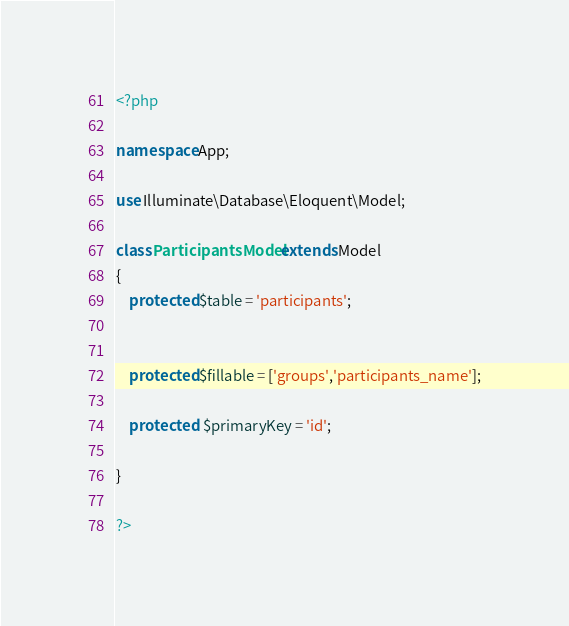<code> <loc_0><loc_0><loc_500><loc_500><_PHP_><?php

namespace App;

use Illuminate\Database\Eloquent\Model;

class ParticipantsModel extends Model
{
    protected $table = 'participants';

  
    protected $fillable = ['groups','participants_name'];

    protected  $primaryKey = 'id';

}

?>



</code> 